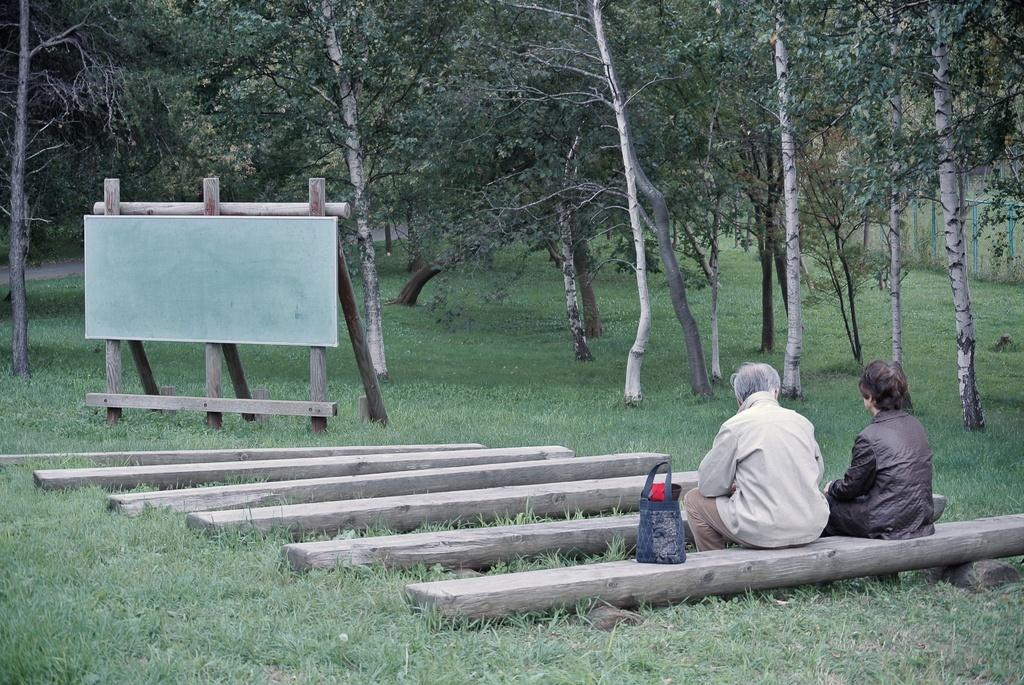What is located at the bottom of the image? There are wooden logs at the bottom of the image. What are the two people in the image doing? Two people are sitting on a log. What object can be seen in the image besides the wooden logs and people? There is a bag in the image. What can be seen in the background of the image? There is a board visible in the background, and trees are also present. How many legs can be seen on the people in the image? The image does not show the legs of the people, so it is not possible to determine the number of legs visible. What time of day is depicted in the image? The provided facts do not give any information about the time of day, so it cannot be determined from the image. 